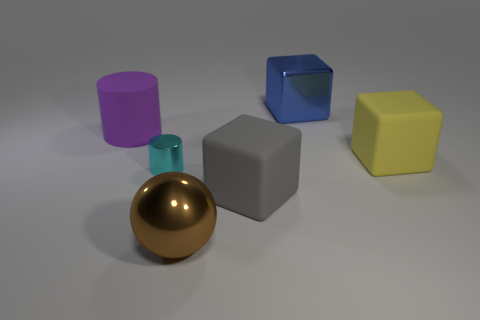What is the color of the cylinder? The cylinder in the image has a vibrant, reflective gold color. 